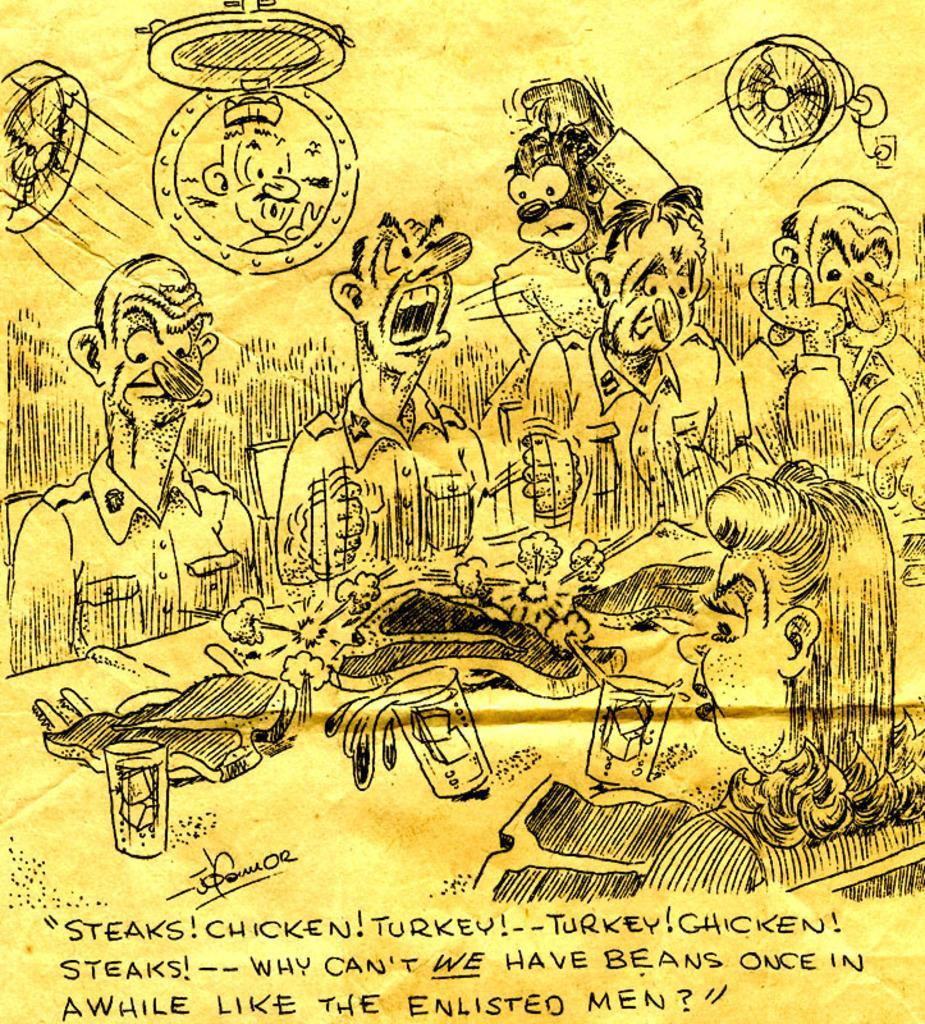How would you summarize this image in a sentence or two? In this image we can see some cartoon images, and text on a paper. 